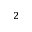<formula> <loc_0><loc_0><loc_500><loc_500>_ { 2 }</formula> 